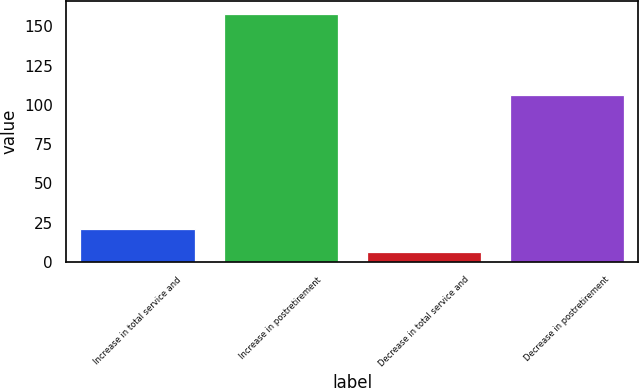Convert chart. <chart><loc_0><loc_0><loc_500><loc_500><bar_chart><fcel>Increase in total service and<fcel>Increase in postretirement<fcel>Decrease in total service and<fcel>Decrease in postretirement<nl><fcel>21.2<fcel>158<fcel>6<fcel>106<nl></chart> 